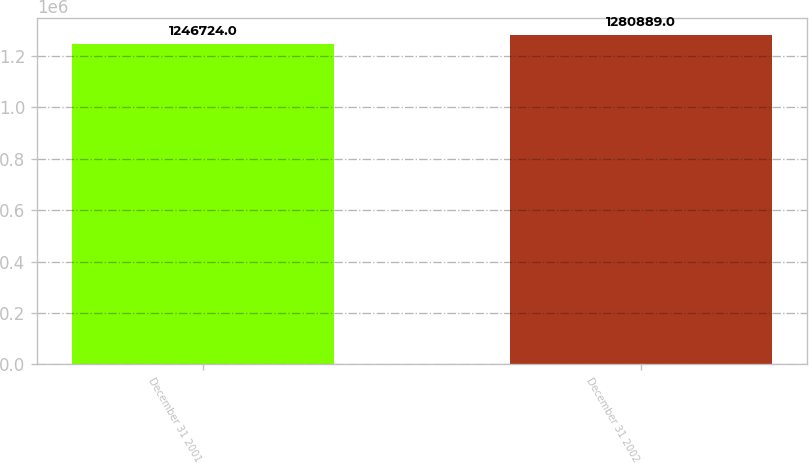Convert chart. <chart><loc_0><loc_0><loc_500><loc_500><bar_chart><fcel>December 31 2001<fcel>December 31 2002<nl><fcel>1.24672e+06<fcel>1.28089e+06<nl></chart> 